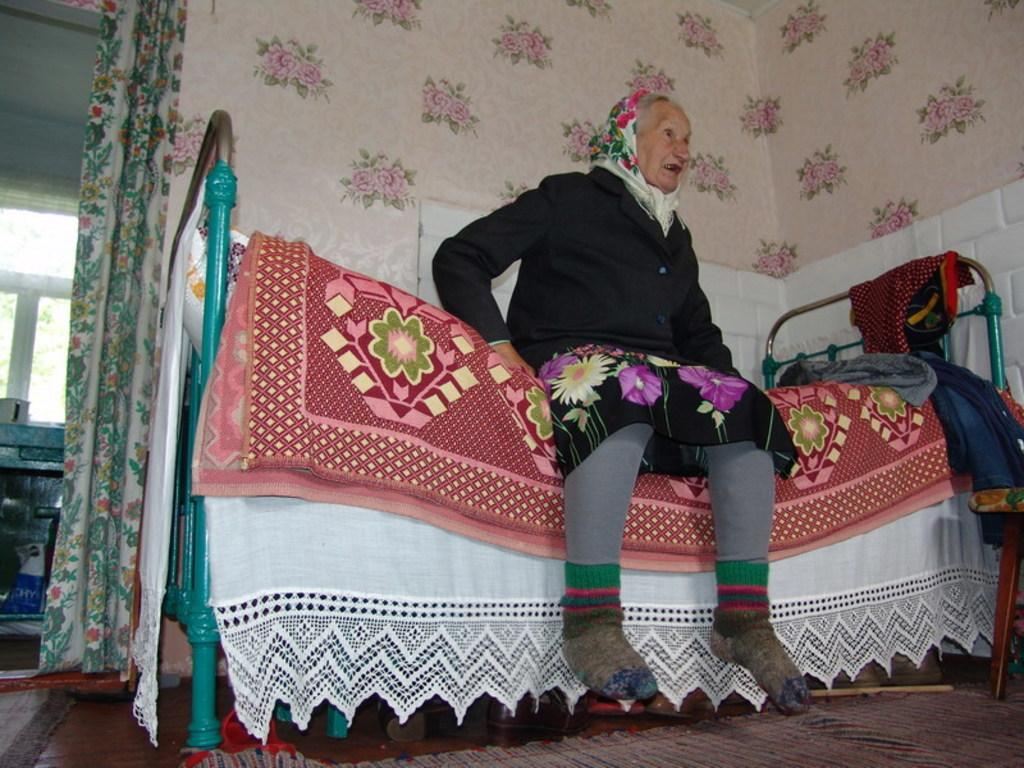Who is the main subject in the image? There is an old lady in the image. What is the old lady doing in the image? The old lady is sitting on a bed. What can be seen in the background of the image? There is a wall visible in the background of the image. What language is the old lady speaking in the image? There is no indication of the old lady speaking in the image, so it cannot be determined what language she might be using. 